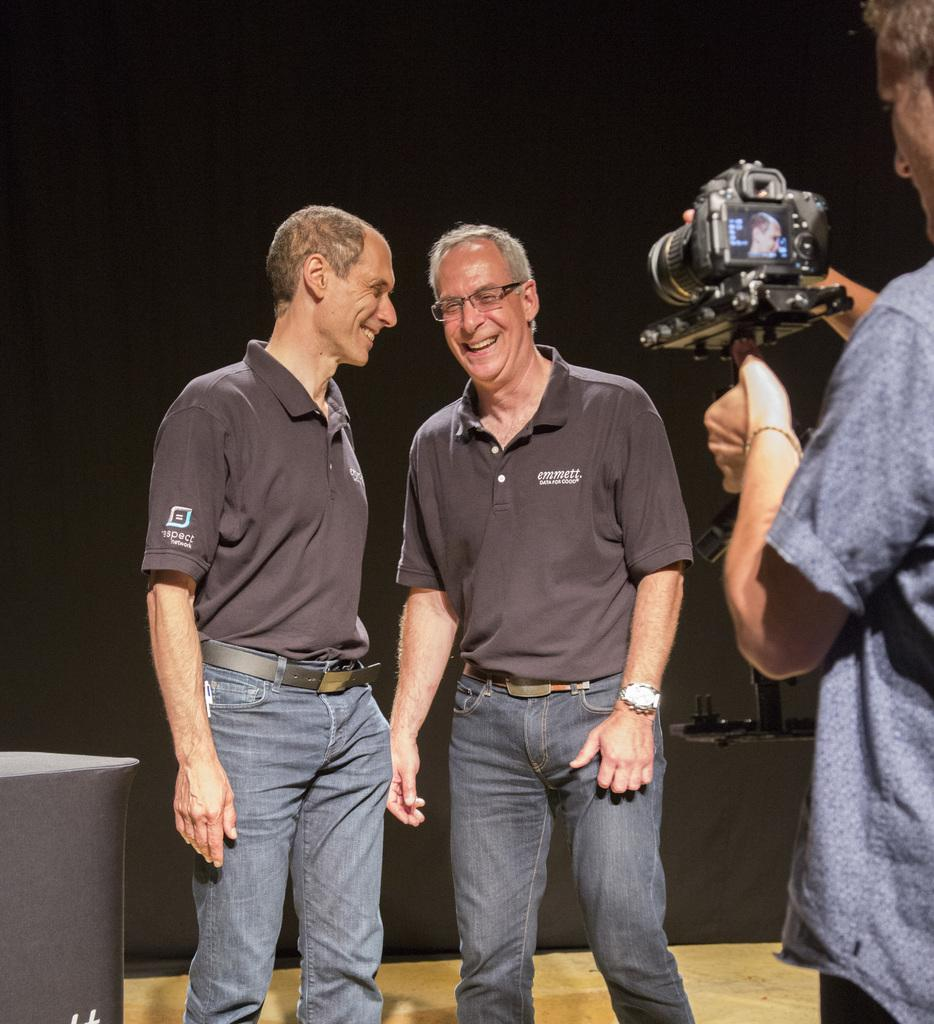What are the two men in the image doing? The two men in the image are standing and laughing. Who is capturing the moment in the image? There is another man capturing the moment with a camera in the image. What can be seen in the background of the image? There is a white cloth visible in the background of the image. What type of government is depicted in the image? There is no depiction of a government in the image; it features two men standing and laughing, another man capturing the moment with a camera, and a white cloth in the background. 